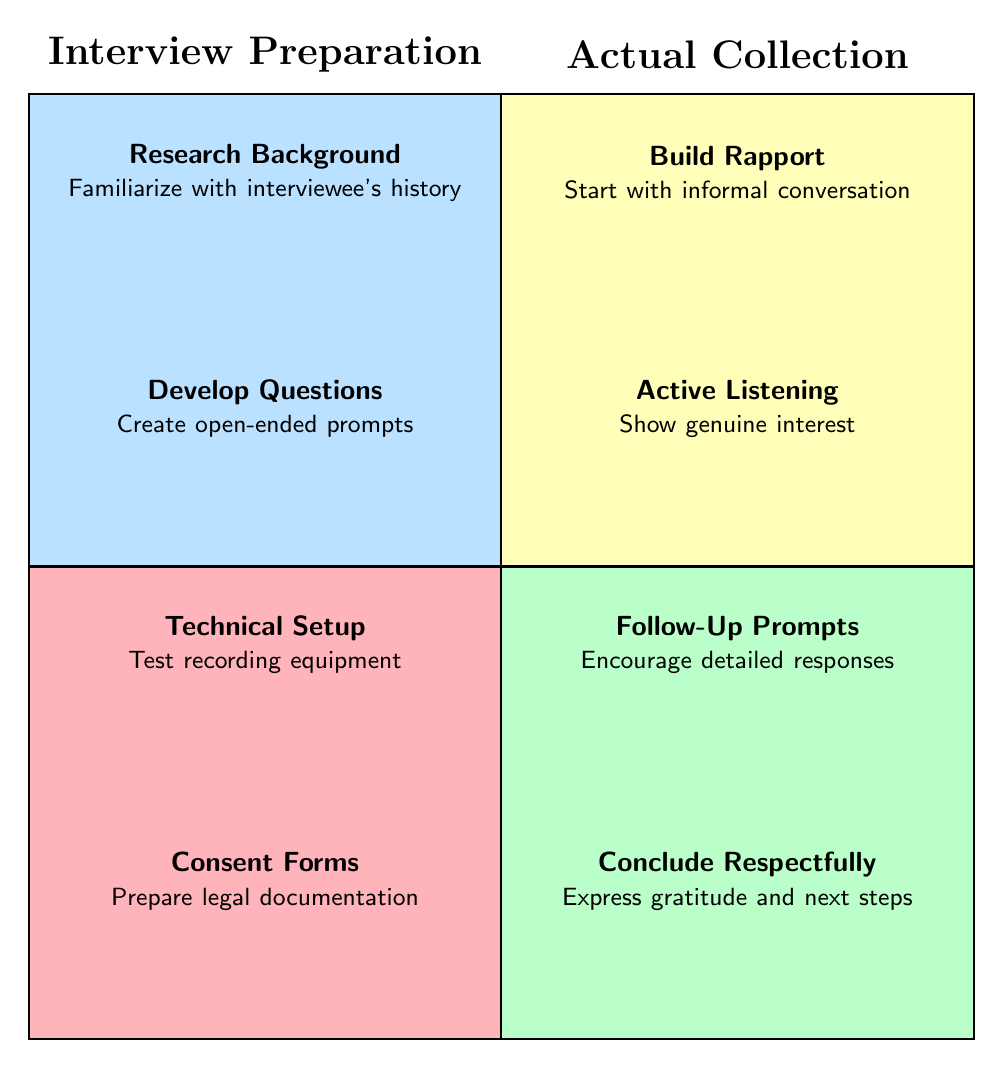What is the content of the first node in Interview Preparation? The first node in the Interview Preparation section is "Research Background," which is located in the upper left quadrant of the diagram.
Answer: Research Background How many nodes are there in the Actual Collection section? The Actual Collection section has four nodes: "Build Rapport," "Active Listening," "Follow-Up Prompts," and "Conclude Respectfully," found in the lower right quadrant.
Answer: 4 What is the last node in the Interview Preparation quadrant? The last node in the Interview Preparation quadrant is "Consent Forms," located at the bottom of the left quadrant.
Answer: Consent Forms Which node in Actual Collection corresponds with "Develop Questions"? "Develop Questions" is in Interview Preparation and does not have a direct correspondence in Actual Collection. However, the focus on conversation aligns with "Build Rapport."
Answer: Build Rapport (related) What is the primary focus of the "Follow-Up Prompts" node? The primary focus of "Follow-Up Prompts" is to encourage detailed responses, which helps to gather more information from the interviewee during the collection phase.
Answer: Encourage detailed responses What is the relationship between "Technical Setup" and "Active Listening"? "Technical Setup" is part of Interview Preparation that ensures the interview can be recorded properly, while "Active Listening" is an approach used during the Actual Collection to engage with the interviewee, forming a sequential process from preparation to collection.
Answer: Preparation to collection What is the theme of the nodes in the lower right quadrant? The theme of the nodes in the lower right quadrant, which represent Actual Collection, focuses on interpersonal communication and gathering information effectively during interviews.
Answer: Interpersonal communication What type of questions are suggested for the "Develop Questions" node? The suggested questions for the "Develop Questions" node should be open-ended prompts, allowing the interviewee to provide detailed and expansive answers.
Answer: Open-ended prompts Which section contains "Test recording equipment"? "Test recording equipment" is located in the Interview Preparation section of the diagram, indicating a preparatory step before the actual interview collection.
Answer: Interview Preparation 